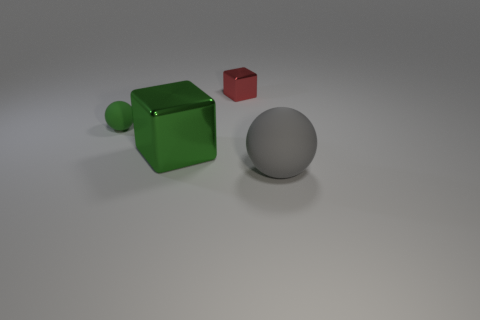Add 2 gray rubber objects. How many objects exist? 6 Subtract 0 purple balls. How many objects are left? 4 Subtract all matte balls. Subtract all small balls. How many objects are left? 1 Add 3 big balls. How many big balls are left? 4 Add 2 tiny green rubber objects. How many tiny green rubber objects exist? 3 